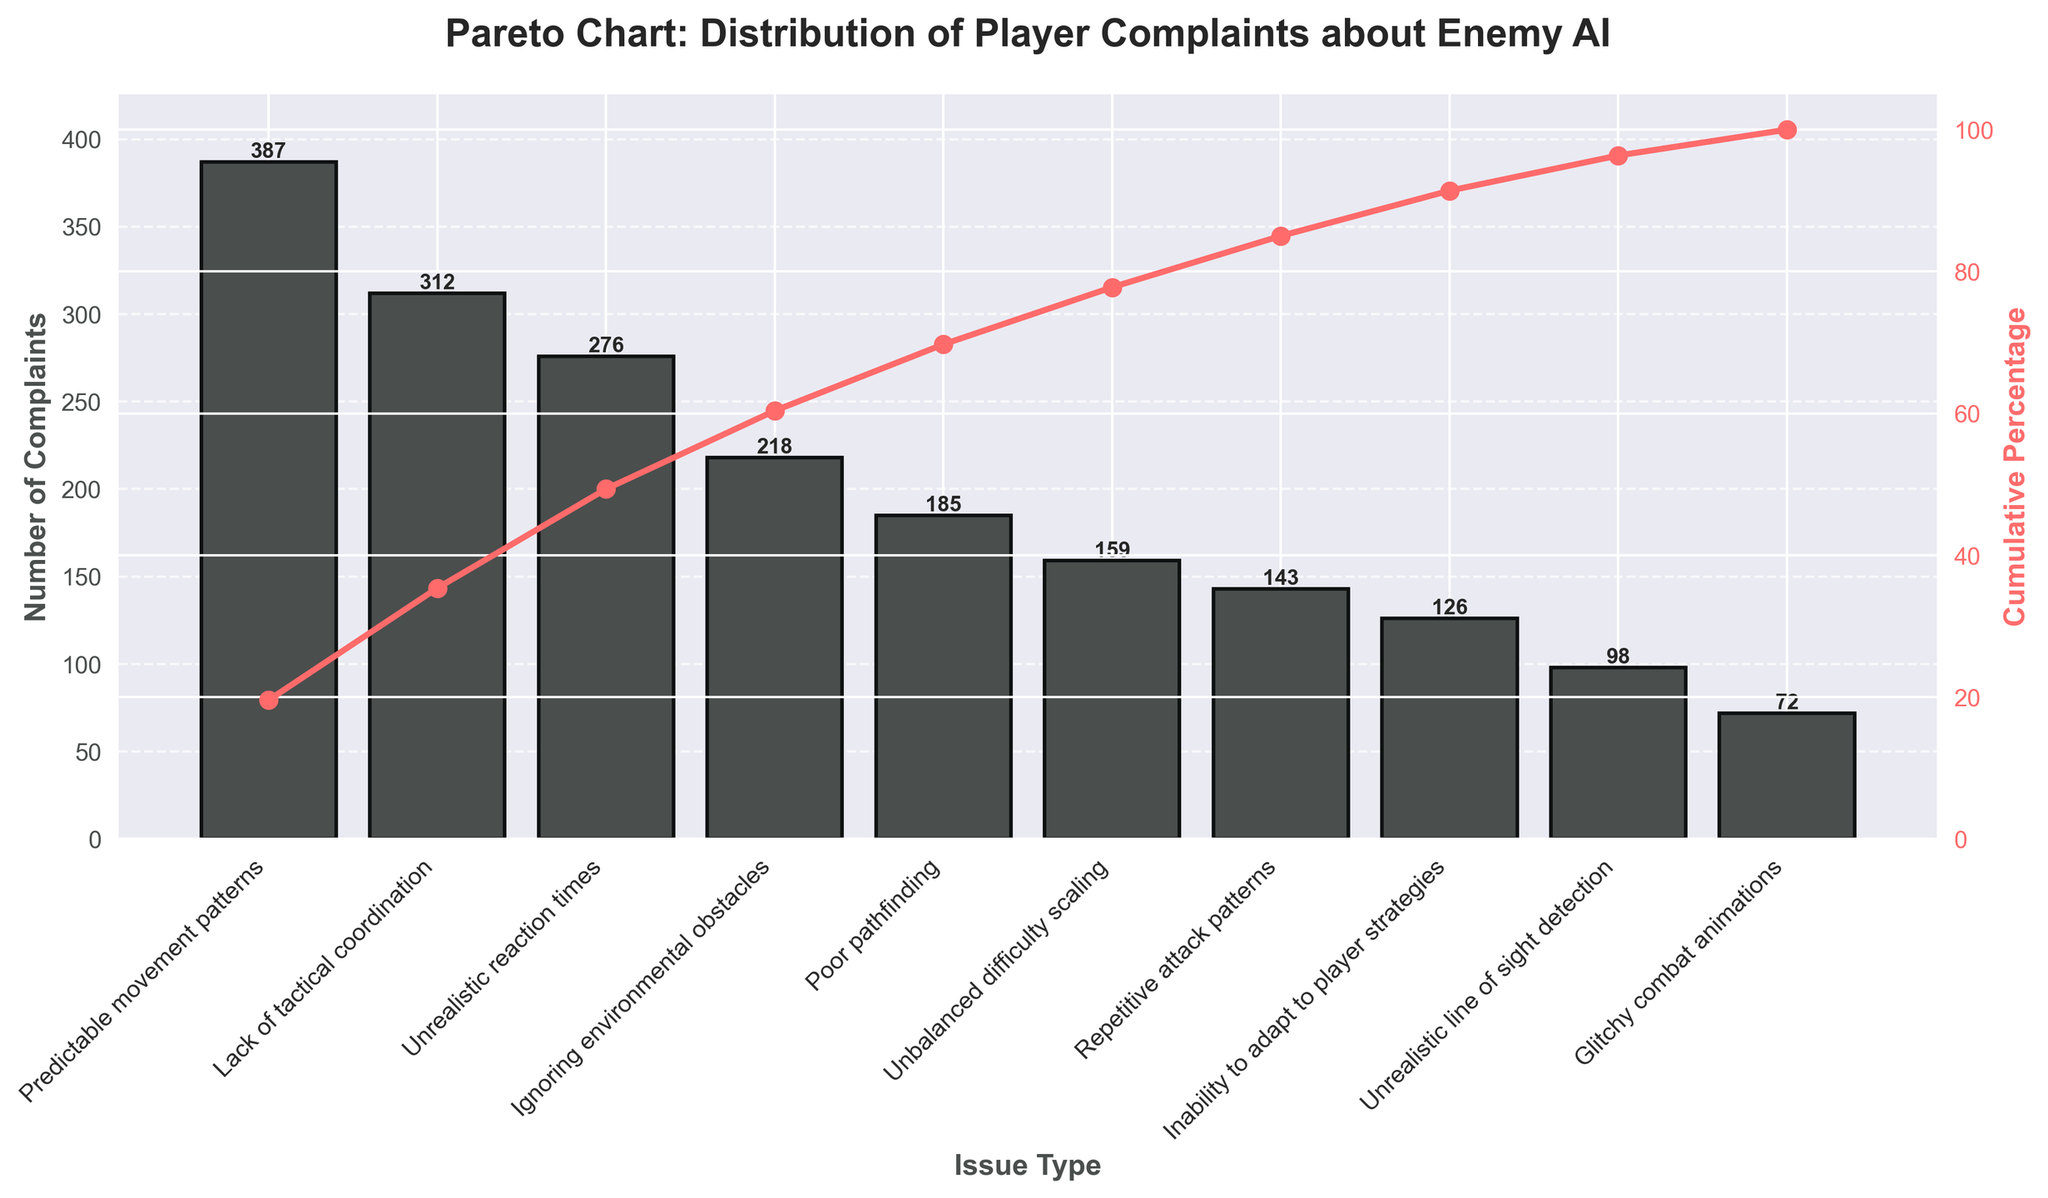What is the title of the chart? The title of the chart is displayed at the top and summarizes the content of the figure. In this case, it states the overall subject and focus of the analysis.
Answer: Pareto Chart: Distribution of Player Complaints about Enemy AI Which issue type received the highest number of complaints? To find the issue type with the highest number of complaints, look for the tallest bar in the bar chart. The corresponding label on the x-axis is the answer.
Answer: Predictable movement patterns What is the cumulative percentage of complaints for the top three issue types? Calculate the cumulative percentage by summing the complaints for the top three issues and dividing by the total number of complaints, then multiplying by 100. In the chart, this is visualized with the cumulative percentage line. The three issues are "Predictable movement patterns", "Lack of tactical coordination", and "Unrealistic reaction times". 387+312+276 = 975, Sum = 1,976, So the cumulative percentage is (975/1976)*100
Answer: 49.37% How much higher is the number of complaints for "Predictable movement patterns" compared to "Poor pathfinding"? Find the height of the bars representing each issue type and subtract the number of complaints for "Poor pathfinding" from "Predictable movement patterns". 387 - 185 = 202
Answer: 202 Which issue type has the lowest number of complaints? Identify the shortest bar in the bar chart and refer to the x-axis label below it for the issue type with the fewest complaints.
Answer: Glitchy combat animations How many complaints are there in total? Sum the number of complaints for all issue types listed in the chart. 387 + 312 + 276 +218 +185 + 159 + 143 +126 + 98 + 72
Answer: 1976 What is the percentage of complaints for "Unbalanced difficulty scaling"? Divide the number of complaints for "Unbalanced difficulty scaling" by the total number of complaints and multiply by 100 to get the percentage. (159/1976)*100
Answer: 8.04% Which issue type is just below "Ignoring environmental obstacles" in terms of the number of complaints? Look at the bar immediately to the right of "Ignoring environmental obstacles" which has one less number of complaints.
Answer: Poor pathfinding How does the cumulative percentage line behave across the issues? Discuss the trend shown by the line plotting the cumulative percentage as more issue types are included. It's an increasing line, starting from the first issue type to the last, revealing how each subsequent issue contributes to the cumulative total.
Answer: It continuously increases from left to right 